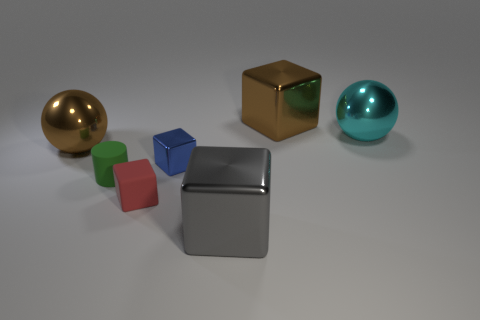There is a big object that is in front of the brown ball; what is its color?
Provide a short and direct response. Gray. Is the number of blocks that are on the left side of the tiny blue shiny thing the same as the number of brown shiny cubes in front of the cyan sphere?
Offer a very short reply. No. What is the material of the big sphere that is right of the big metallic object in front of the matte block?
Ensure brevity in your answer.  Metal. What number of things are green spheres or large shiny balls left of the cyan shiny thing?
Make the answer very short. 1. The brown block that is the same material as the cyan object is what size?
Provide a short and direct response. Large. Is the number of tiny green matte cylinders on the right side of the gray object greater than the number of green rubber cubes?
Your response must be concise. No. What is the size of the block that is both to the left of the large gray thing and in front of the tiny metal thing?
Provide a succinct answer. Small. What is the material of the brown thing that is the same shape as the red matte thing?
Give a very brief answer. Metal. There is a object to the right of the brown shiny block; does it have the same size as the green cylinder?
Your answer should be very brief. No. The large shiny object that is left of the cyan metallic sphere and on the right side of the large gray thing is what color?
Offer a very short reply. Brown. 